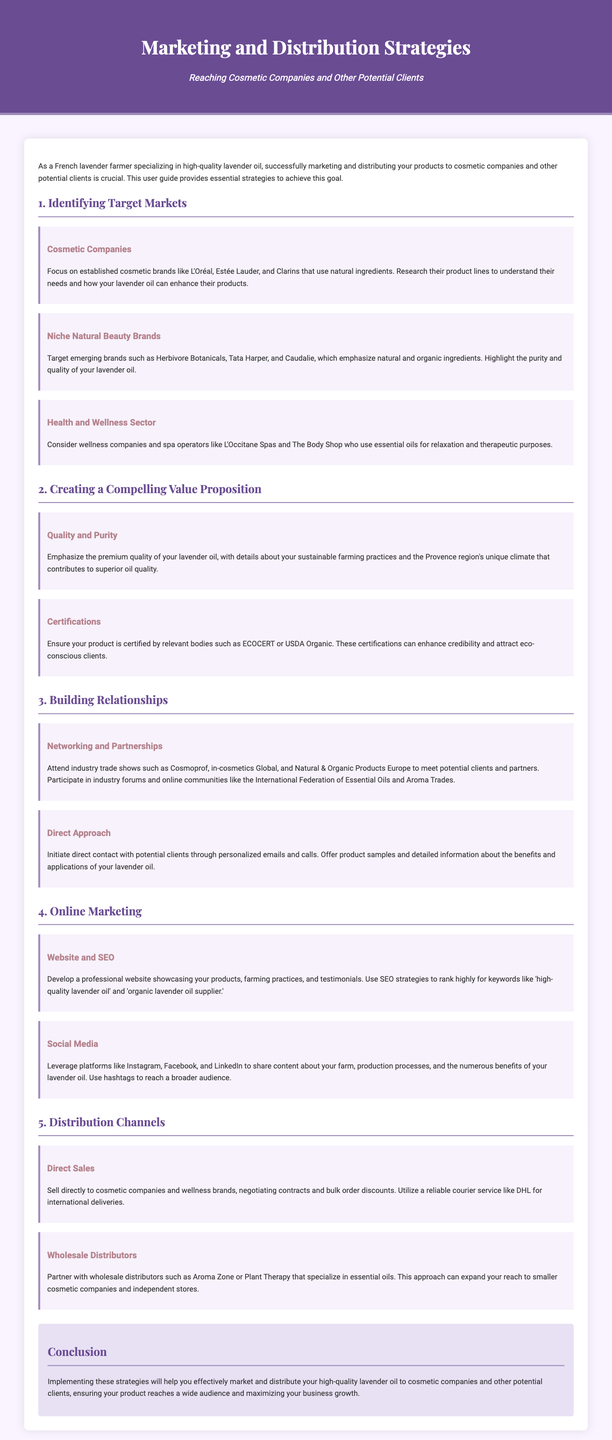What are the three target markets mentioned? The document identifies three target markets: cosmetic companies, niche natural beauty brands, and health and wellness sector.
Answer: cosmetic companies, niche natural beauty brands, health and wellness sector Which certification is recommended for enhancing credibility? The document suggests certifications like ECOCERT or USDA Organic to attract eco-conscious clients.
Answer: ECOCERT or USDA Organic Name two major trade shows to attend for networking. The document lists two trade shows: Cosmoprof and in-cosmetics Global as important events for networking.
Answer: Cosmoprof, in-cosmetics Global What is the primary focus of the value proposition? The document emphasizes quality and purity as the main aspect of the value proposition for lavender oil.
Answer: quality and purity How should direct sales be executed according to the guide? The document advises negotiating contracts and offering bulk order discounts for direct sales to cosmetic companies and wellness brands.
Answer: negotiating contracts and bulk order discounts What social media platforms are suggested for marketing? The document suggests using platforms like Instagram, Facebook, and LinkedIn for marketing purposes.
Answer: Instagram, Facebook, LinkedIn What is the objective of the guide? The objective of the guide is to provide strategies for marketing and distributing high-quality lavender oil to potential clients.
Answer: provide strategies for marketing and distributing high-quality lavender oil Which companies are highlighted in the niche natural beauty brands section? The document mentions emerging brands like Herbivore Botanicals, Tata Harper, and Caudalie in the niche natural beauty brands section.
Answer: Herbivore Botanicals, Tata Harper, Caudalie 